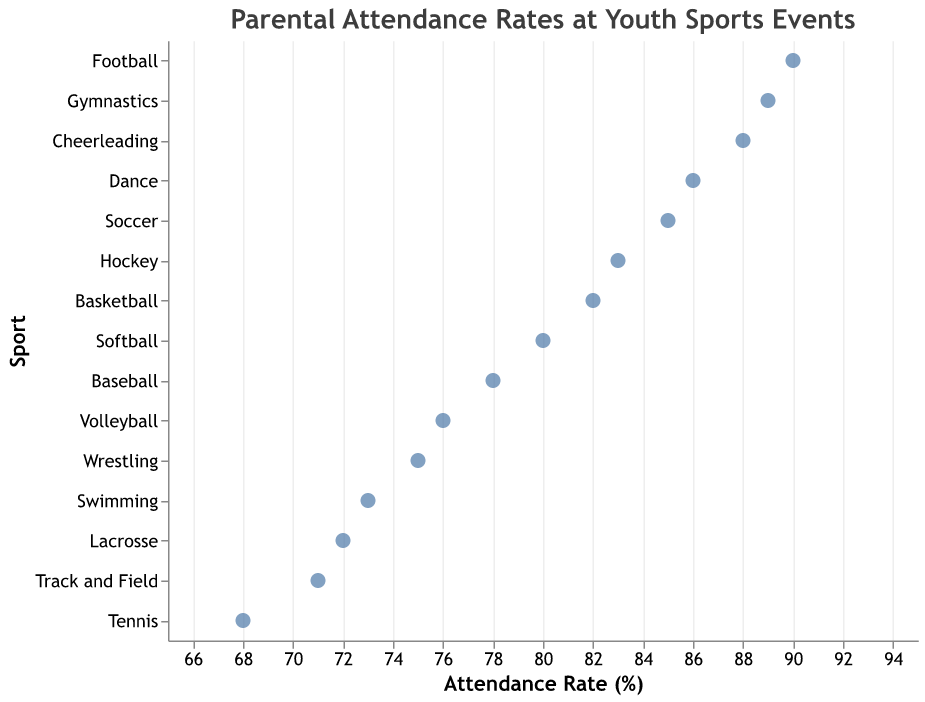What's the highest parental attendance rate among youth sports events? Look at all data points to identify the sport with the highest attendance rate.
Answer: Football (90%) What's the lowest parental attendance rate among youth sports events? Look at all data points to identify the sport with the lowest attendance rate.
Answer: Tennis (68%) What is the title of the plot? Read the title text displayed at the top of the plot.
Answer: Parental Attendance Rates at Youth Sports Events Which sport has a higher attendance rate, Soccer or Softball? Compare the attendance rates of Soccer (85%) and Softball (80%).
Answer: Soccer How many sports have an attendance rate above 80%? Count the number of data points with attendance rates over 80%.
Answer: 8 Which sports have exactly equal attendance rates? Identify pairs or groups of sports that share the same attendance rate.
Answer: None are equal What's the average attendance rate for Swimming, Volleyball, and Tennis? Sum the attendance rates of Swimming (73), Volleyball (76), and Tennis (68), then divide by 3. (73+76+68)/3 = 217/3
Answer: 72.33% How does the attendance rate of Cheerleading compare to that of Gymnastics? Compare the attendance rates of Cheerleading (88%) and Gymnastics (89%).
Answer: Gymnastics has a higher rate Which sports have attendance rates between 70% and 80%? Identify the sports that fall within the 70%-80% range: Baseball (78), Volleyball (76), Wrestling (75), Swimming (73), Track and Field (71), and Lacrosse (72).
Answer: Baseball, Volleyball, Wrestling, Swimming, Track and Field, Lacrosse What's the range of parental attendance rates across all the sports? Subtract the minimum attendance rate (68% for Tennis) from the maximum attendance rate (90% for Football). 90 - 68
Answer: 22% 